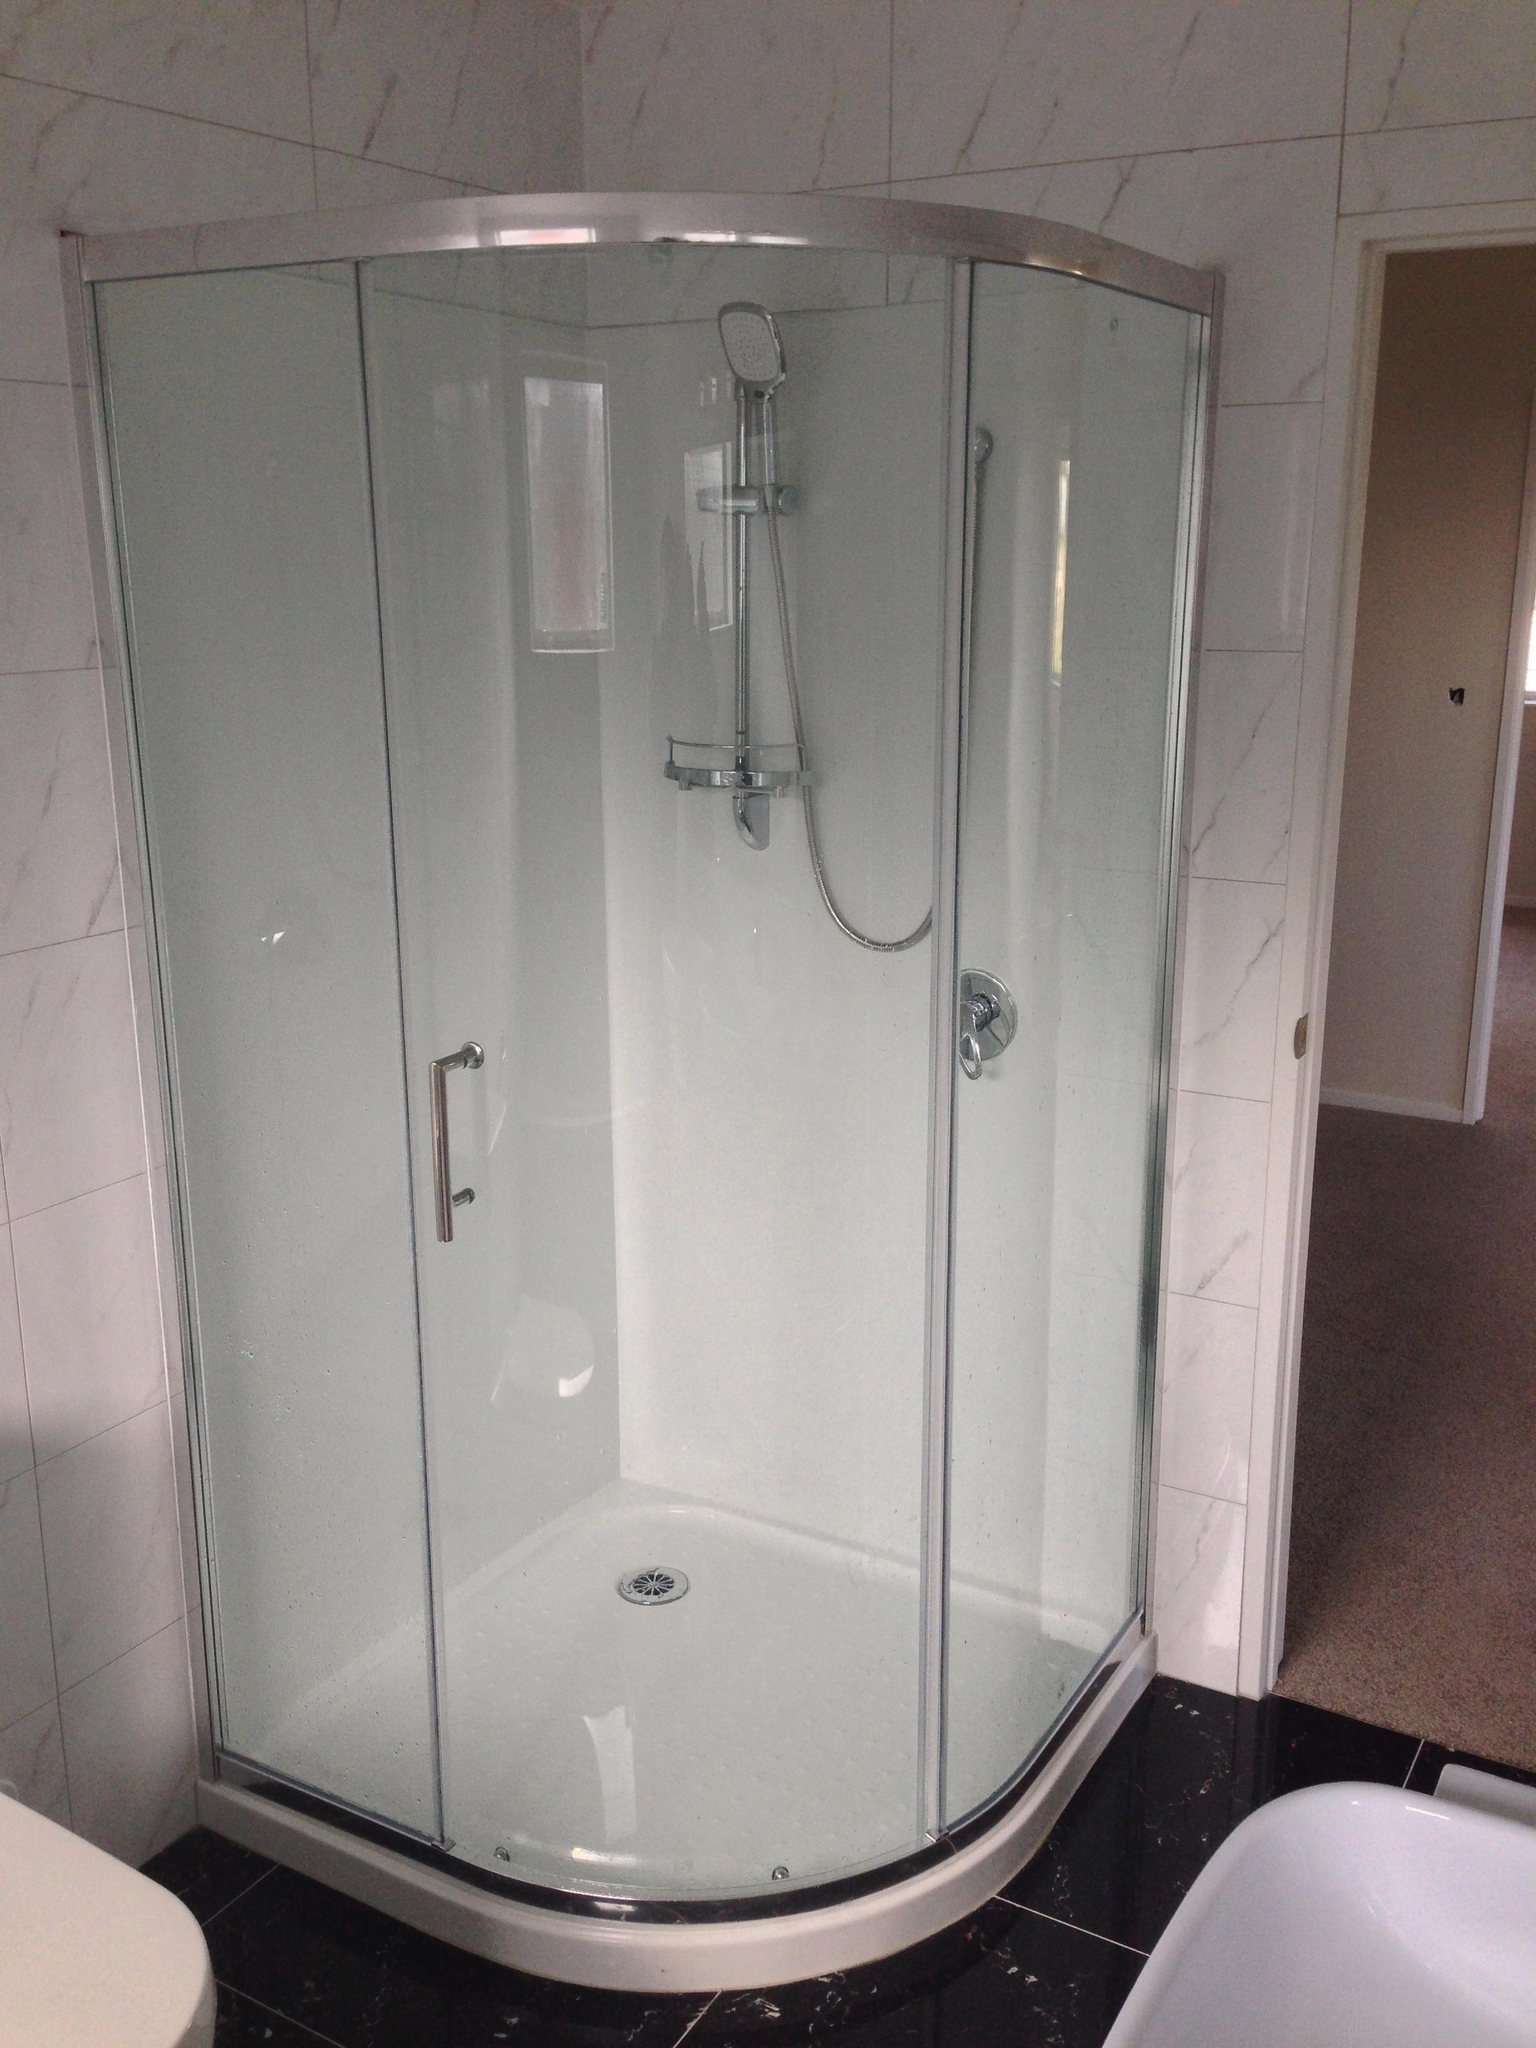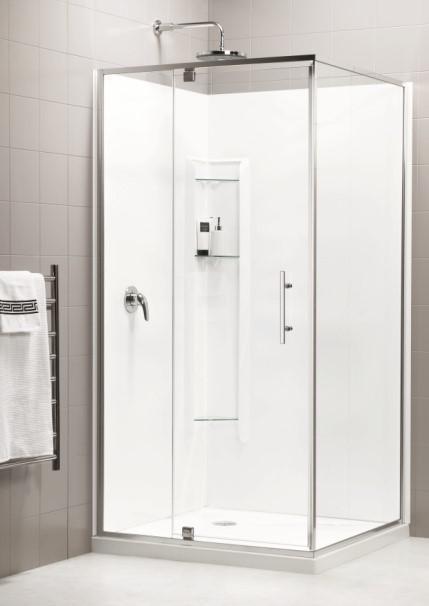The first image is the image on the left, the second image is the image on the right. For the images displayed, is the sentence "The shower in the image on the left if against a solid color background." factually correct? Answer yes or no. No. 